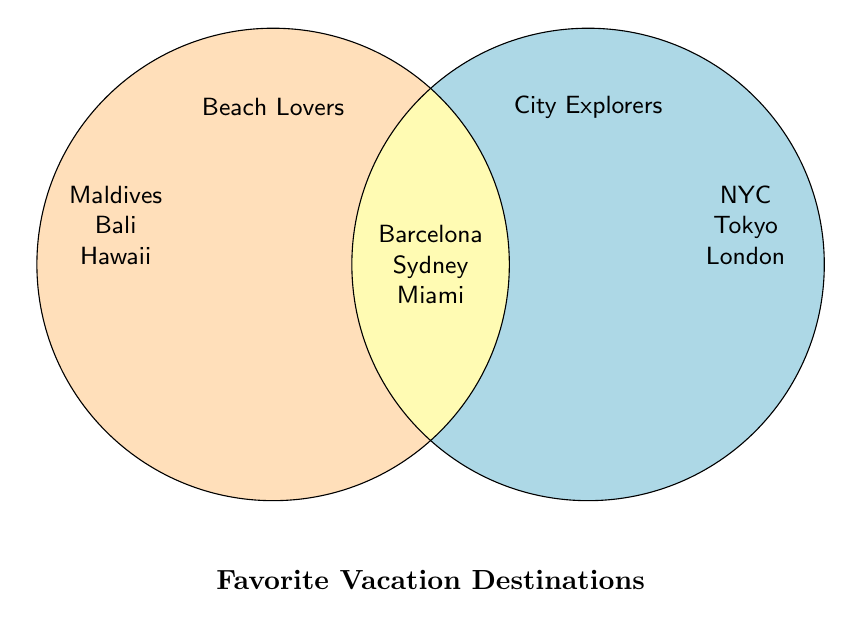What are the vacation destinations exclusive to Beach Lovers? The Beach Lovers' section only includes destinations not shared with City Explorers. From the figure's left circle, those are Maldives, Bali, Hawaii, Seychelles, and Cancun.
Answer: Maldives, Bali, Hawaii, Seychelles, Cancun What colors represent Beach Lovers and City Explorers in the diagram? Beach Lovers is represented in a light beige color, and City Explorers is represented in a light blue color.
Answer: Light beige, light blue Which destinations are shared by both Beach Lovers and City Explorers? The shared section is found in the overlapping part of the circles, listing destinations enjoyed by both groups: Barcelona, Sydney, San Francisco, Rio de Janeiro, Miami, and Singapore.
Answer: Barcelona, Sydney, San Francisco, Rio de Janeiro, Miami, Singapore How many destinations in total are listed for City Explorers? Count the destinations exclusive to City Explorers plus those also enjoyed by both. Exclusive to City Explorers: NYC, Tokyo, London, Paris, Dubai, Rome, Hong Kong. Shared: Barcelona, Sydney, San Francisco, Rio de Janeiro, Miami, Singapore. Total: 13.
Answer: 13 Are there any destinations listed only for City Explorers beginning with "H"? Checking the City Explorers' exclusive section, the only listed destination starting with "H" is Hong Kong.
Answer: Yes, Hong Kong Which destination appears both for Beach Lovers and City Explorers and starts with "S"? Among shared destinations, the one starting with "S" is Sydney and San Francisco.
Answer: Sydney, San Francisco How many destinations are exclusive to Beach Lovers? Count the names within the Beach Lovers circle: Maldives, Bali, Hawaii, Seychelles, Cancun. This totals to 5.
Answer: 5 Which group (Beach Lovers, City Explorers, or Both) has a destination that includes the name "Tokyo"? From the list, Tokyo is a destination exclusive to City Explorers. Refer to the right circle for verification.
Answer: City Explorers Is Miami listed under Beach Lovers, City Explorers, or Both? Miami is found in the overlapping middle section indicating it is enjoyed by both groups.
Answer: Both How many destinations in total are shared by Both groups? Count the destinations in the overlapping section: Barcelona, Sydney, San Francisco, Rio de Janeiro, Miami, Singapore. This totals to 6.
Answer: 6 